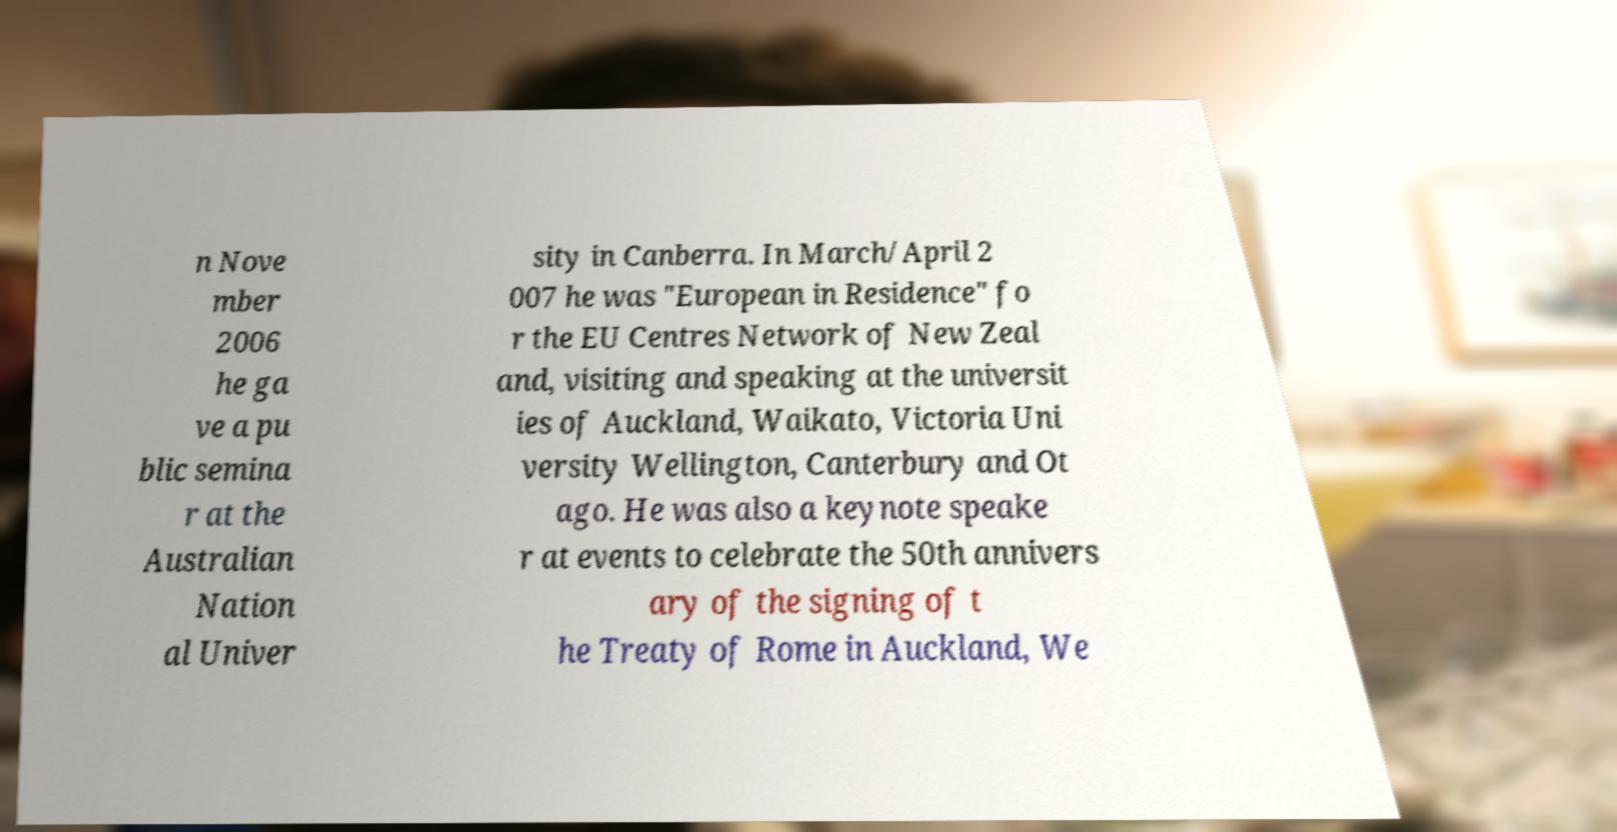For documentation purposes, I need the text within this image transcribed. Could you provide that? n Nove mber 2006 he ga ve a pu blic semina r at the Australian Nation al Univer sity in Canberra. In March/April 2 007 he was "European in Residence" fo r the EU Centres Network of New Zeal and, visiting and speaking at the universit ies of Auckland, Waikato, Victoria Uni versity Wellington, Canterbury and Ot ago. He was also a keynote speake r at events to celebrate the 50th annivers ary of the signing of t he Treaty of Rome in Auckland, We 